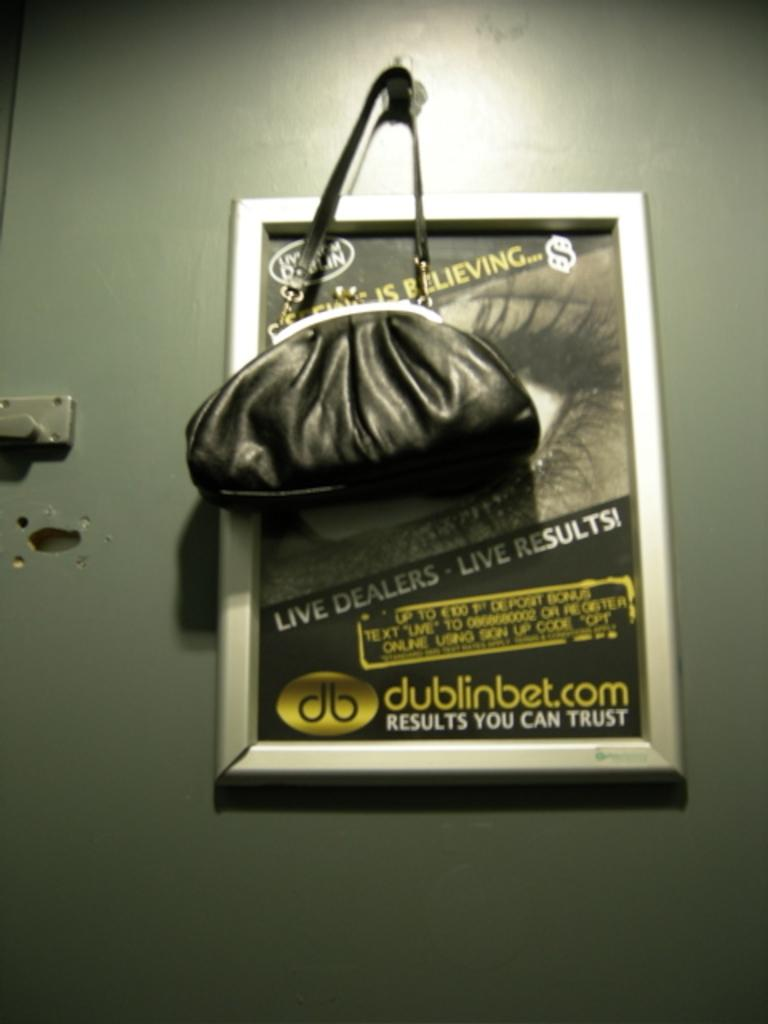What is hanging on the wall in the image? There is a bag hanging on the wall. What else can be seen on the wall in the image? There is a photo frame on the wall. What type of fruit is hanging from the bag on the wall? There is no fruit hanging from the bag on the wall; it is a bag hanging on the wall. 